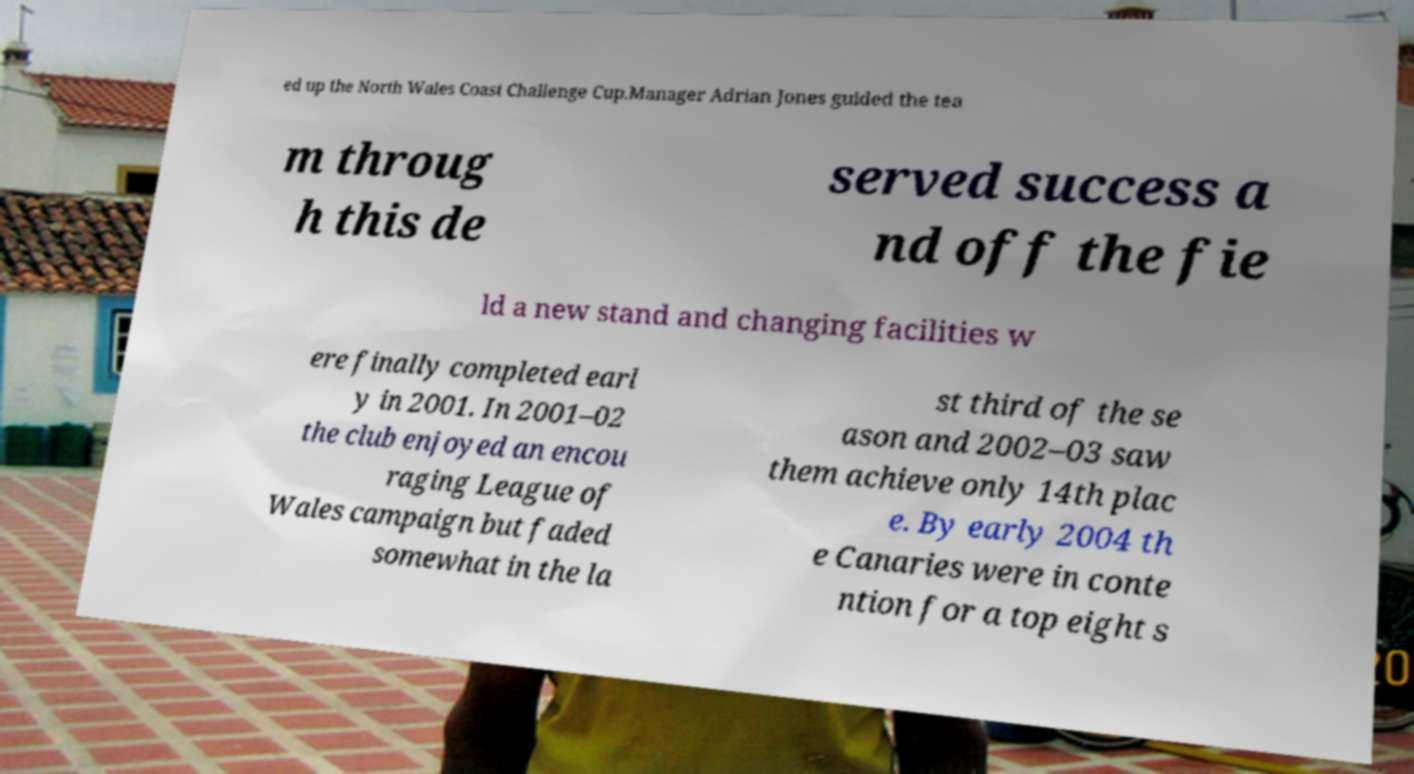Please read and relay the text visible in this image. What does it say? ed up the North Wales Coast Challenge Cup.Manager Adrian Jones guided the tea m throug h this de served success a nd off the fie ld a new stand and changing facilities w ere finally completed earl y in 2001. In 2001–02 the club enjoyed an encou raging League of Wales campaign but faded somewhat in the la st third of the se ason and 2002–03 saw them achieve only 14th plac e. By early 2004 th e Canaries were in conte ntion for a top eight s 